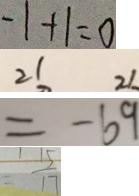Convert formula to latex. <formula><loc_0><loc_0><loc_500><loc_500>- 1 + 1 = 0 
 2 1 2 1 
 = - 6 9 
 \frac { 1 5 } { 1 7 }</formula> 